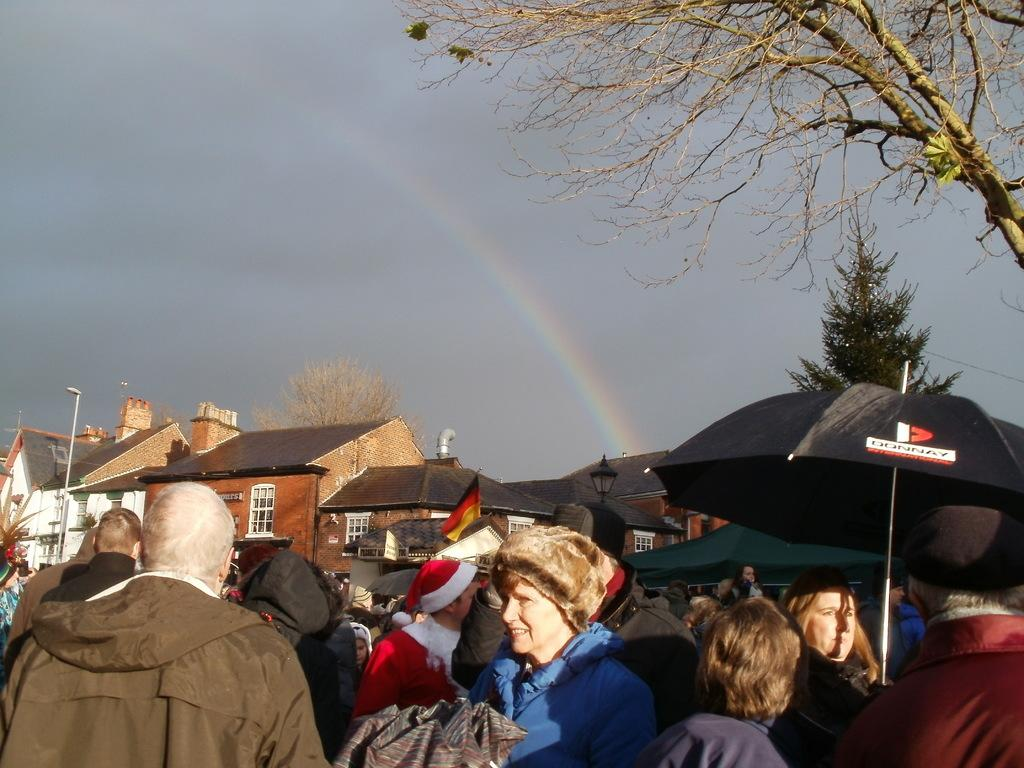Who or what can be seen at the bottom of the image? There are people at the bottom of the image. What can be seen in the distance behind the people? There are houses in the background of the image. What is visible above the houses and people? The sky is visible in the image. What additional feature can be seen in the sky? There is a rainbow in the image in the image. What type of vegetation is on the right side of the image? There are trees to the right side of the image. How many eyes can be seen on the people in the image? There is no information about the number of eyes on the people in the image, as the focus is on their presence and the surrounding environment. 